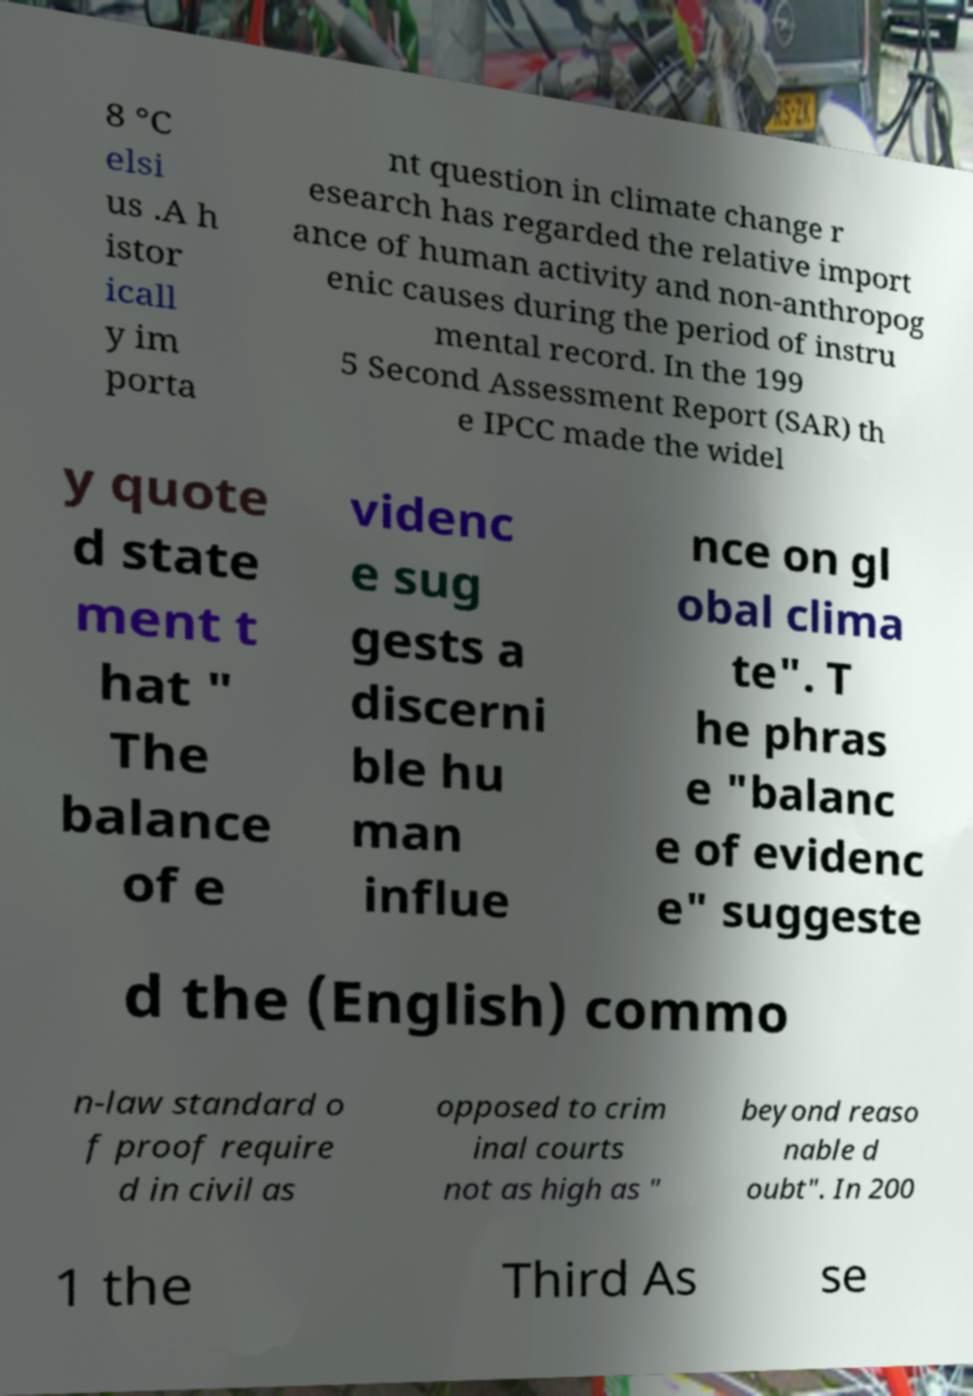For documentation purposes, I need the text within this image transcribed. Could you provide that? 8 °C elsi us .A h istor icall y im porta nt question in climate change r esearch has regarded the relative import ance of human activity and non-anthropog enic causes during the period of instru mental record. In the 199 5 Second Assessment Report (SAR) th e IPCC made the widel y quote d state ment t hat " The balance of e videnc e sug gests a discerni ble hu man influe nce on gl obal clima te". T he phras e "balanc e of evidenc e" suggeste d the (English) commo n-law standard o f proof require d in civil as opposed to crim inal courts not as high as " beyond reaso nable d oubt". In 200 1 the Third As se 